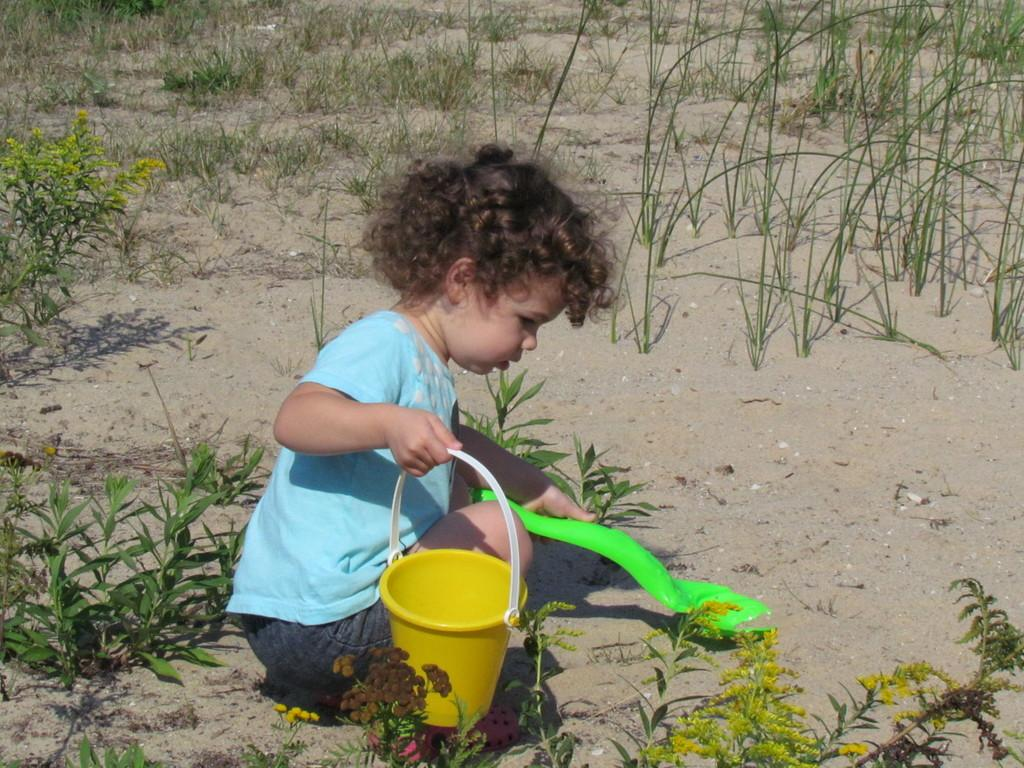What is the main subject of the image? The main subject of the image is a kid. What is the kid holding in their hands? The kid is holding a yellow color bucket and a green color object. What can be seen in the background of the image? There is grass, plants, and sand in the background of the image. How many chickens are present in the image? There are no chickens present in the image. What type of care is the kid providing to the jar in the image? There is no jar present in the image, and therefore no care is being provided. 